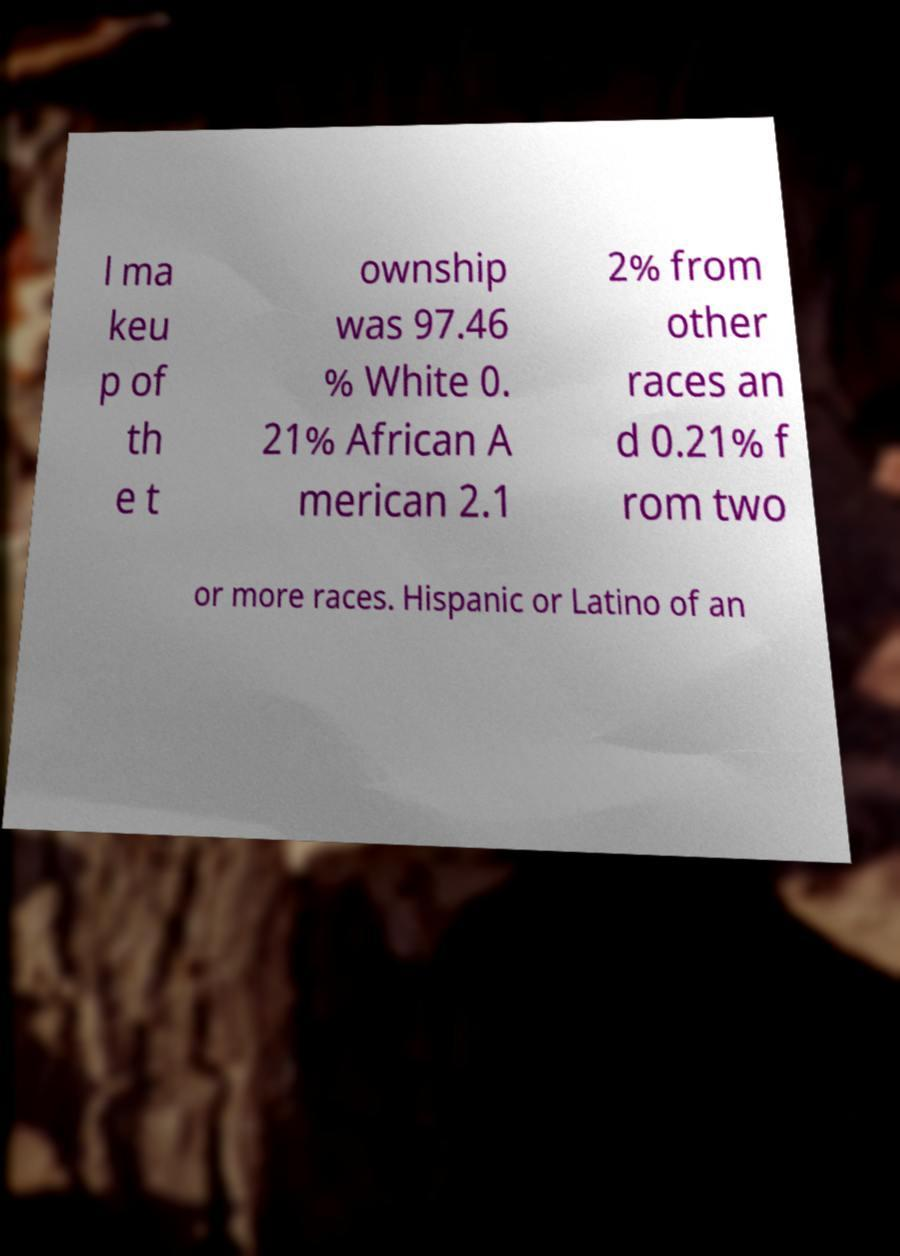I need the written content from this picture converted into text. Can you do that? l ma keu p of th e t ownship was 97.46 % White 0. 21% African A merican 2.1 2% from other races an d 0.21% f rom two or more races. Hispanic or Latino of an 